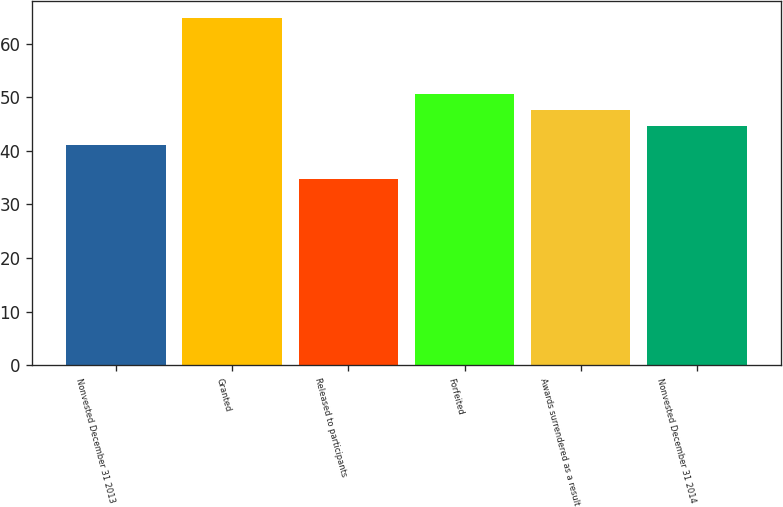Convert chart to OTSL. <chart><loc_0><loc_0><loc_500><loc_500><bar_chart><fcel>Nonvested December 31 2013<fcel>Granted<fcel>Released to participants<fcel>Forfeited<fcel>Awards surrendered as a result<fcel>Nonvested December 31 2014<nl><fcel>41.1<fcel>64.75<fcel>34.68<fcel>50.63<fcel>47.62<fcel>44.55<nl></chart> 